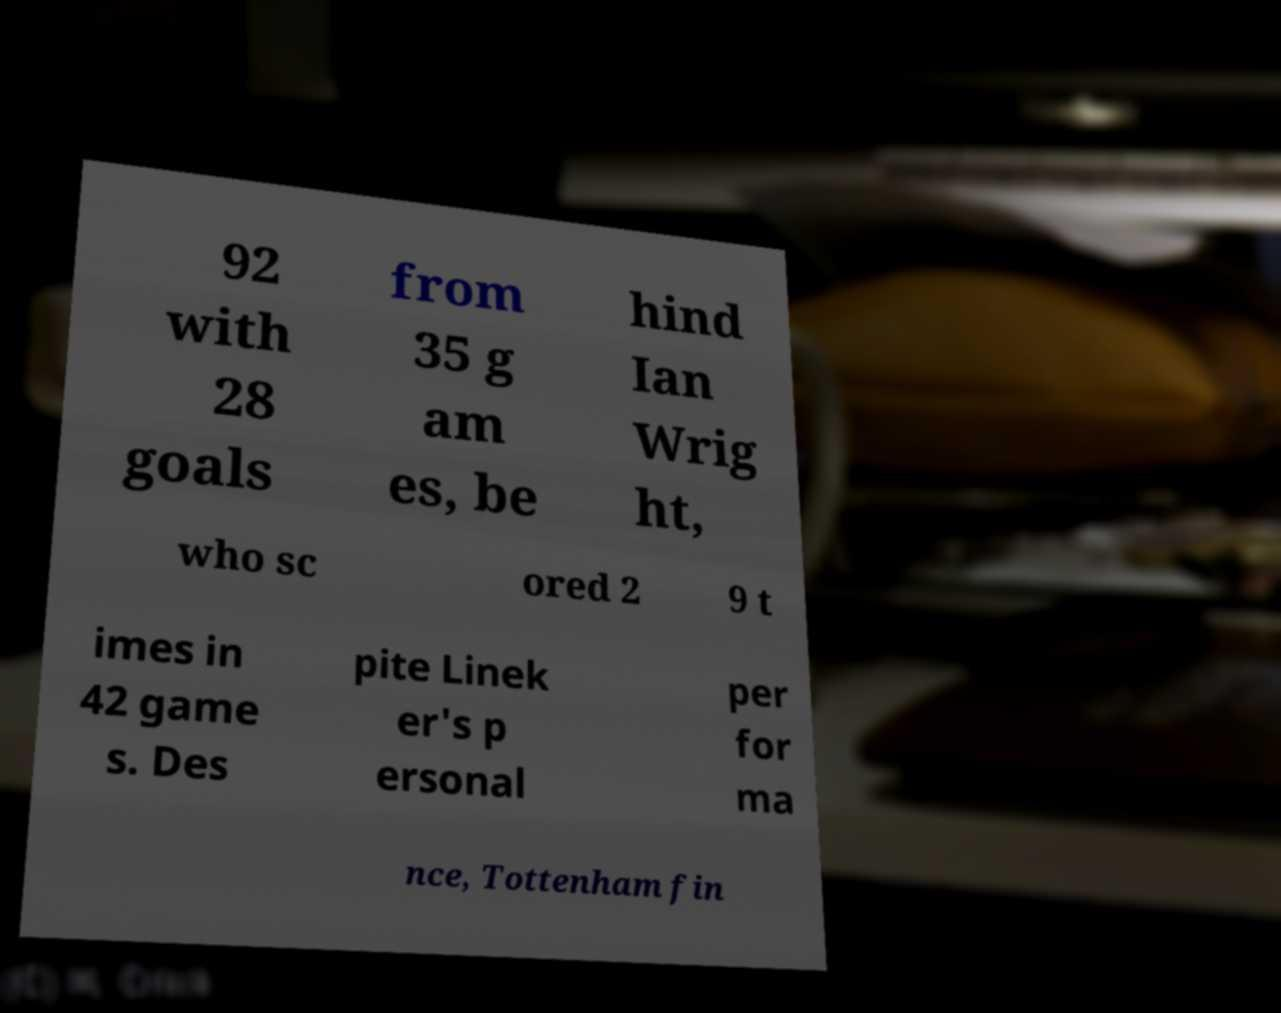Can you accurately transcribe the text from the provided image for me? 92 with 28 goals from 35 g am es, be hind Ian Wrig ht, who sc ored 2 9 t imes in 42 game s. Des pite Linek er's p ersonal per for ma nce, Tottenham fin 